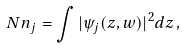<formula> <loc_0><loc_0><loc_500><loc_500>N n _ { j } = \int | \psi _ { j } ( z , { w } ) | ^ { 2 } d z \, ,</formula> 